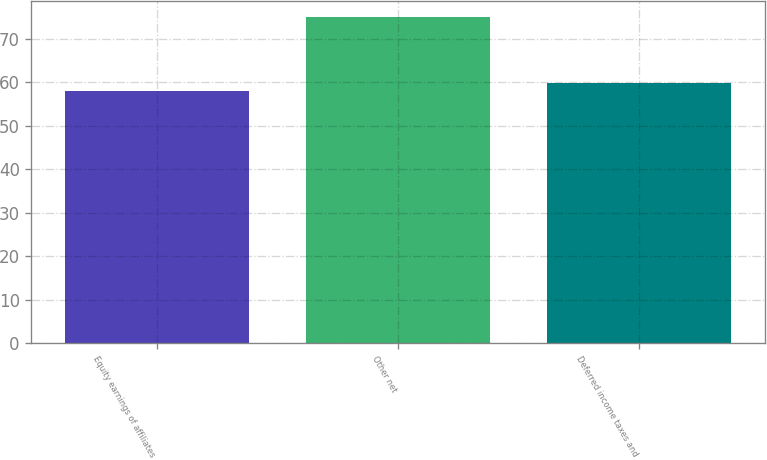Convert chart to OTSL. <chart><loc_0><loc_0><loc_500><loc_500><bar_chart><fcel>Equity earnings of affiliates<fcel>Other net<fcel>Deferred income taxes and<nl><fcel>58<fcel>75<fcel>59.7<nl></chart> 